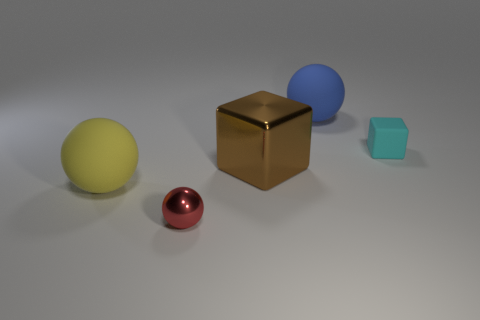Are there more small cubes that are behind the yellow thing than tiny shiny objects that are to the right of the blue ball? From the perspective shown in the image, it appears that there are indeed more small cubes situated behind the golden cube than there are tiny shiny objects to the right of the oversized blue sphere. The small cubes, while less reflective, can be counted more easily, whereas the 'tiny shiny objects' could refer to the smaller spheres whose quantity is limited in comparison. 